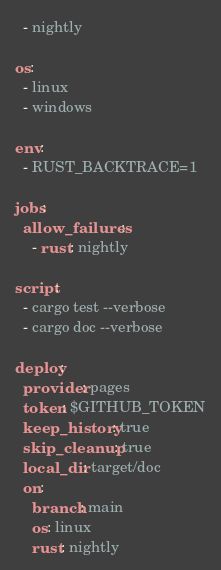<code> <loc_0><loc_0><loc_500><loc_500><_YAML_>  - nightly

os:
  - linux
  - windows

env:
  - RUST_BACKTRACE=1

jobs:
  allow_failures:
    - rust: nightly

script:
  - cargo test --verbose
  - cargo doc --verbose

deploy:
  provider: pages
  token: $GITHUB_TOKEN
  keep_history: true
  skip_cleanup: true
  local_dir: target/doc
  on:
    branch: main
    os: linux
    rust: nightly
</code> 